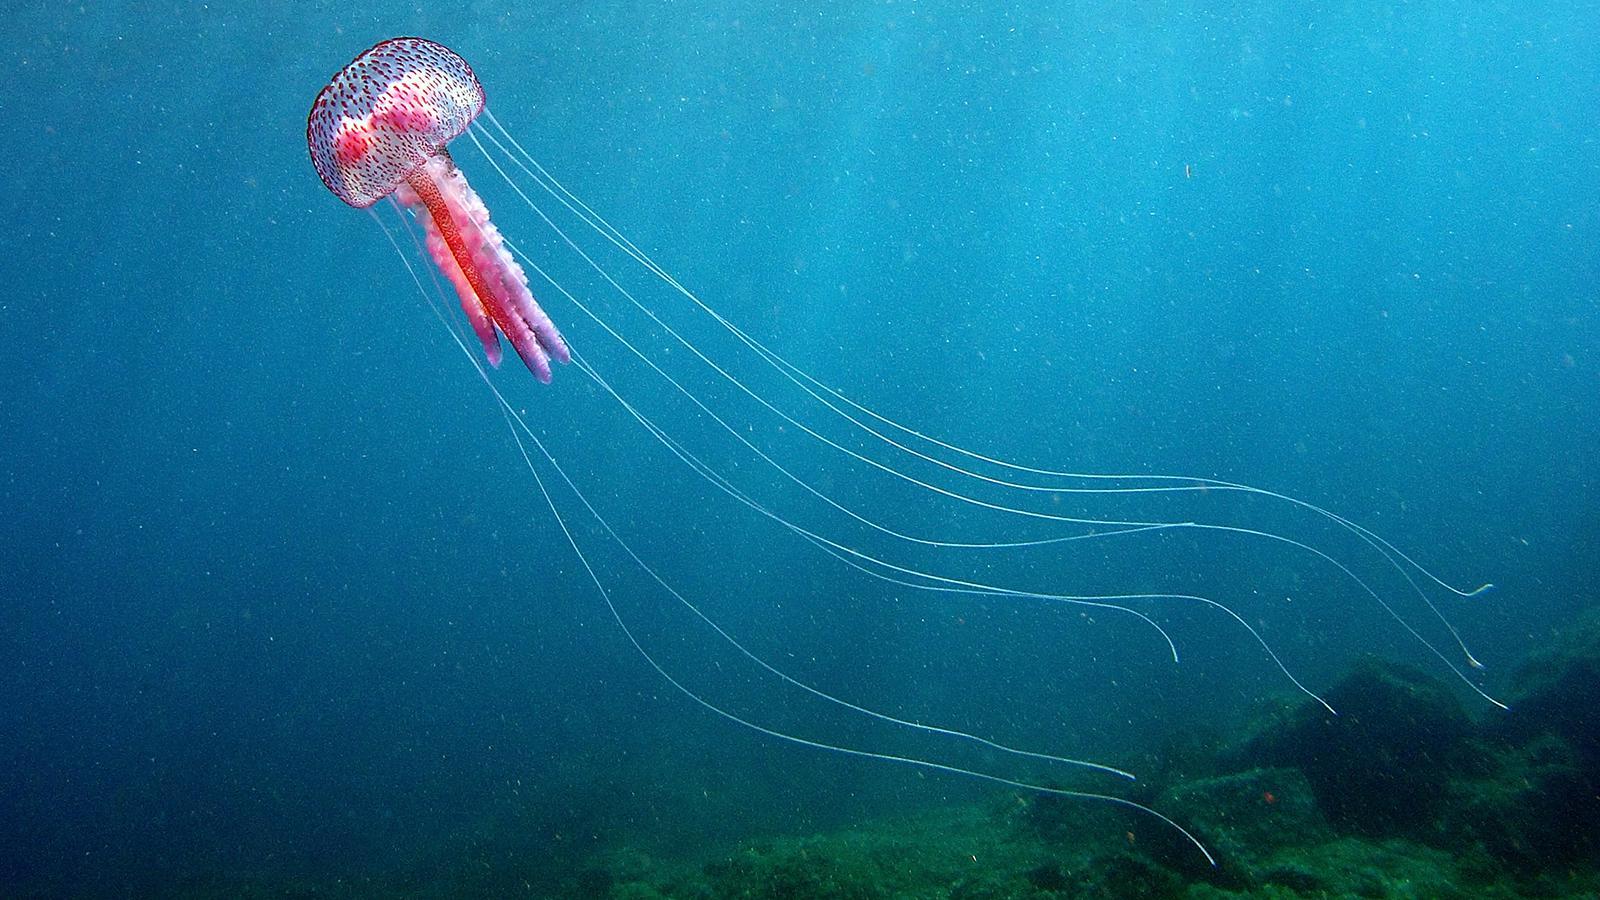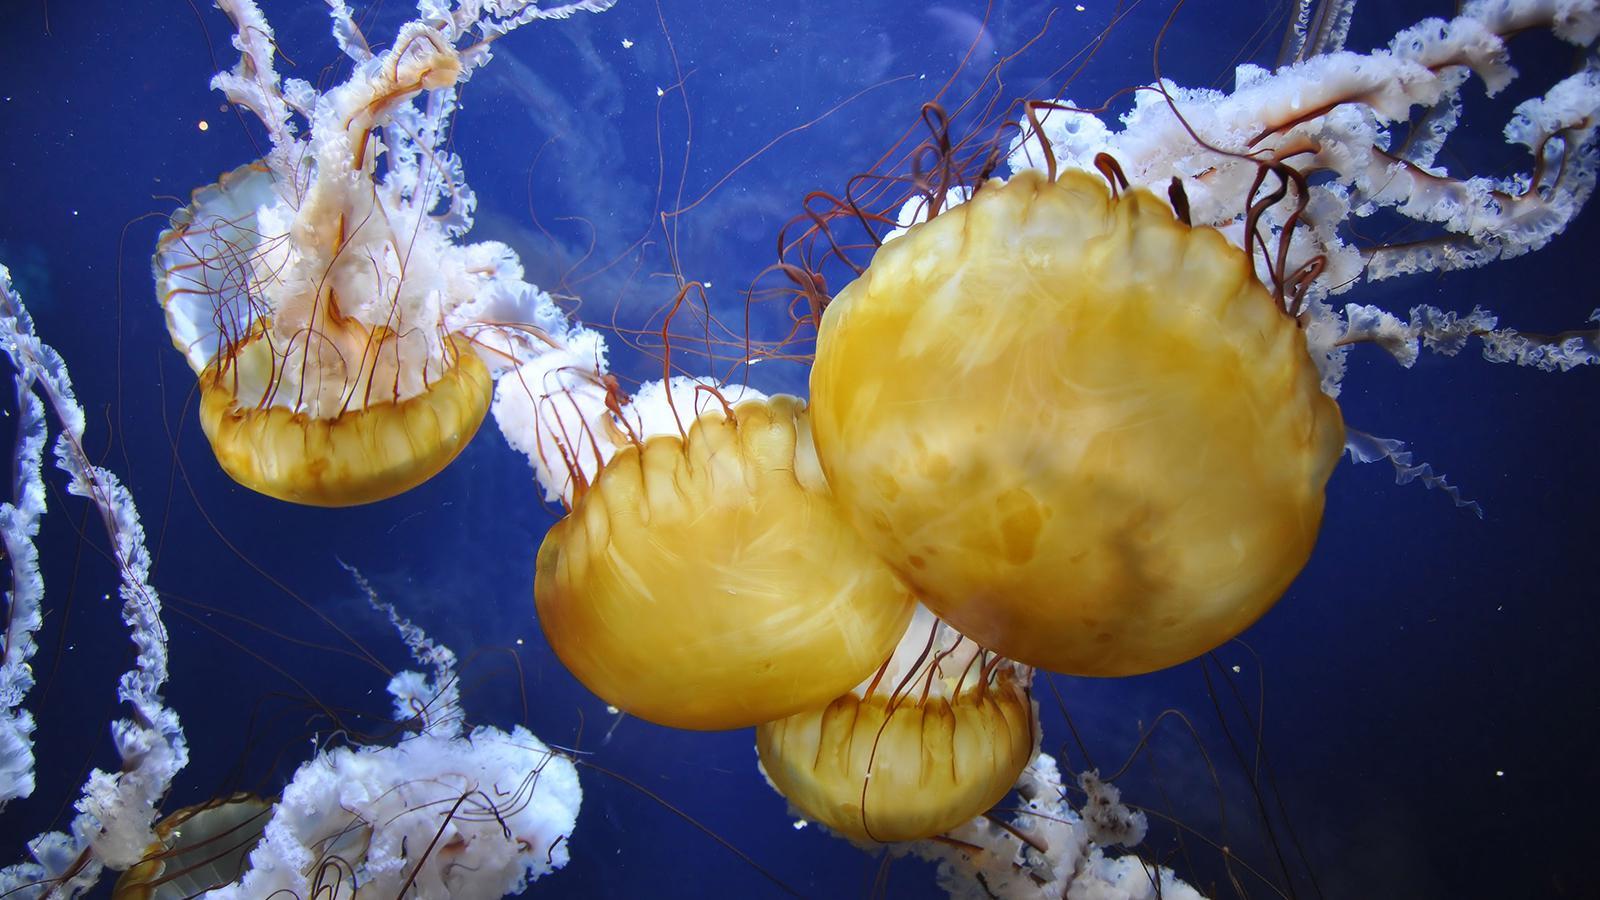The first image is the image on the left, the second image is the image on the right. Considering the images on both sides, is "One jellyfish is swimming toward the right." valid? Answer yes or no. No. The first image is the image on the left, the second image is the image on the right. Given the left and right images, does the statement "One image contains multiple jellyfish, and one image contains a single orange jellyfish with long 'ruffled' tendrils on a solid blue backdrop." hold true? Answer yes or no. No. 